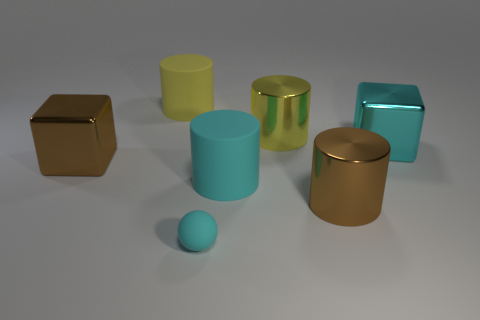Subtract 1 cylinders. How many cylinders are left? 3 Add 1 tiny gray cubes. How many objects exist? 8 Subtract all blocks. How many objects are left? 5 Add 4 cyan blocks. How many cyan blocks are left? 5 Add 5 large yellow matte cylinders. How many large yellow matte cylinders exist? 6 Subtract 0 gray balls. How many objects are left? 7 Subtract all small cyan matte things. Subtract all cyan cylinders. How many objects are left? 5 